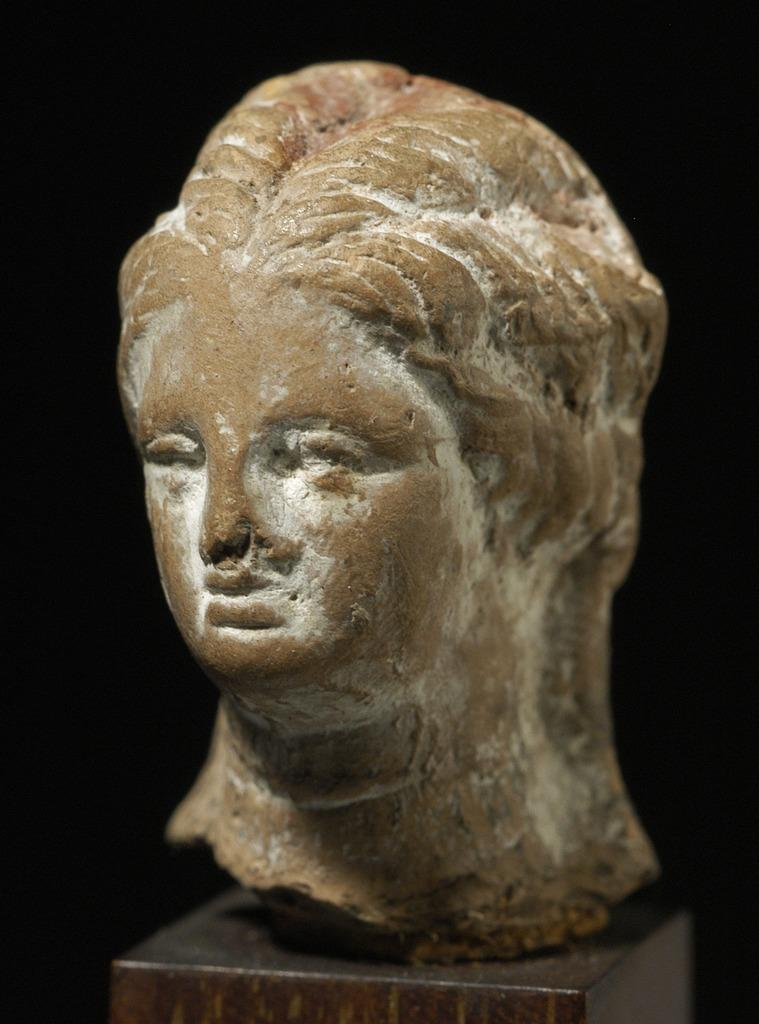What is the main subject in the image? There is a statue in the image. How is the statue positioned in relation to the stand? The statue is on a stand. Where is the statue located within the image? The statue is in the center of the image. What type of cork is used to hold the statue in place in the image? There is no cork present in the image, and the statue is not held in place by any visible means. 